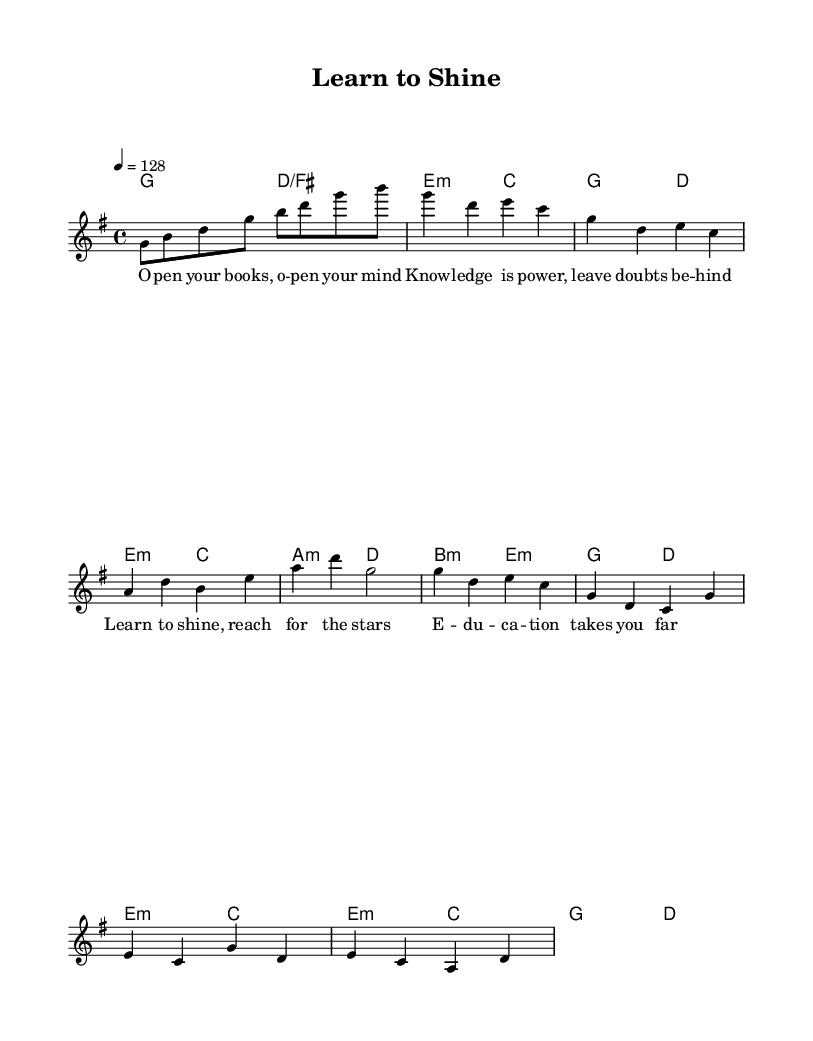What is the key signature of this music? The key signature is G major, which has one sharp (F#). This is indicated at the beginning of the sheet music.
Answer: G major What is the time signature of this music? The time signature is 4/4, meaning there are four beats in each measure and a quarter note receives one beat. This is also indicated at the beginning of the sheet music.
Answer: 4/4 What is the tempo marking indicated in the music? The tempo marking is 128 beats per minute, indicated by the instruction "4 = 128" which means a quarter note equals 128 beats per minute.
Answer: 128 Which musical section follows the pre-chorus? The section following the pre-chorus is the chorus. By looking at the structure laid out in the music, after the pre-chorus, the chorus is indicated next.
Answer: Chorus How many measures are in the verse section? The verse section has four measures. This can be counted by observing the melody and harmonies labeled in the verse segment.
Answer: Four What is the main theme of the lyrics in the chorus? The main theme of the lyrics in the chorus focuses on motivation and the value of education, as indicated by the lines encouraging reaching for the stars and the importance of education.
Answer: Motivation How does the music reflect traditional K-Pop elements? The music reflects traditional K-Pop elements through its catchy melody and structured sections, typically seen in K-Pop songs, combined with uplifting lyrics that inspire personal growth, aligning with the genre's emphasis on positivity and self-improvement.
Answer: Uplifting 